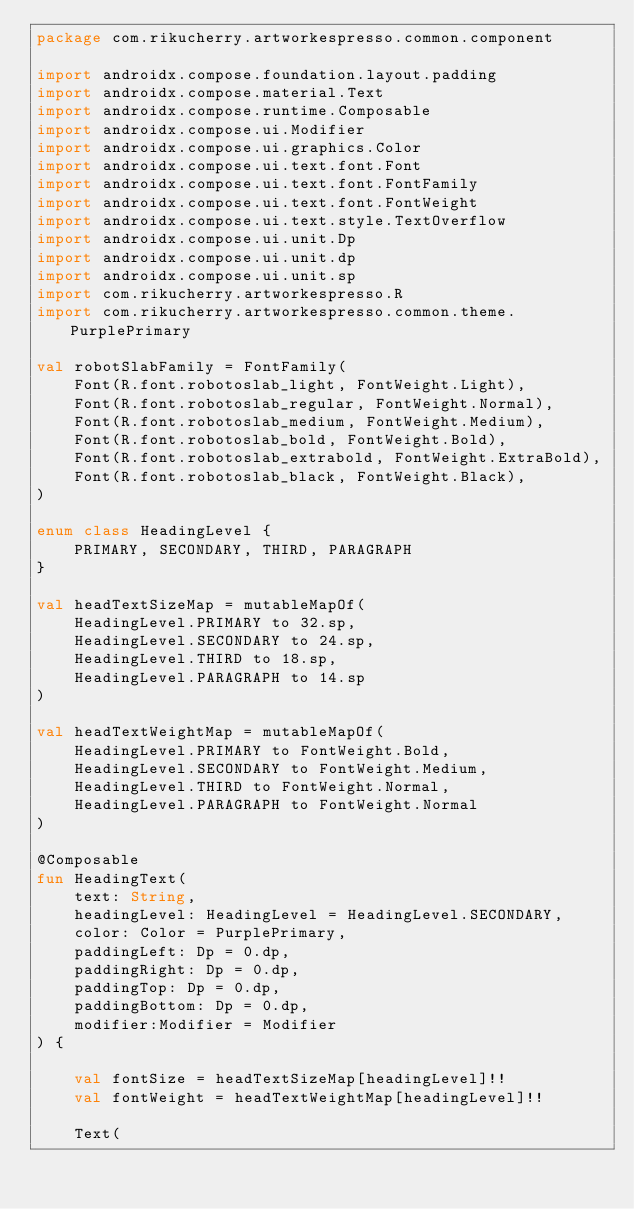Convert code to text. <code><loc_0><loc_0><loc_500><loc_500><_Kotlin_>package com.rikucherry.artworkespresso.common.component

import androidx.compose.foundation.layout.padding
import androidx.compose.material.Text
import androidx.compose.runtime.Composable
import androidx.compose.ui.Modifier
import androidx.compose.ui.graphics.Color
import androidx.compose.ui.text.font.Font
import androidx.compose.ui.text.font.FontFamily
import androidx.compose.ui.text.font.FontWeight
import androidx.compose.ui.text.style.TextOverflow
import androidx.compose.ui.unit.Dp
import androidx.compose.ui.unit.dp
import androidx.compose.ui.unit.sp
import com.rikucherry.artworkespresso.R
import com.rikucherry.artworkespresso.common.theme.PurplePrimary

val robotSlabFamily = FontFamily(
    Font(R.font.robotoslab_light, FontWeight.Light),
    Font(R.font.robotoslab_regular, FontWeight.Normal),
    Font(R.font.robotoslab_medium, FontWeight.Medium),
    Font(R.font.robotoslab_bold, FontWeight.Bold),
    Font(R.font.robotoslab_extrabold, FontWeight.ExtraBold),
    Font(R.font.robotoslab_black, FontWeight.Black),
)

enum class HeadingLevel {
    PRIMARY, SECONDARY, THIRD, PARAGRAPH
}

val headTextSizeMap = mutableMapOf(
    HeadingLevel.PRIMARY to 32.sp,
    HeadingLevel.SECONDARY to 24.sp,
    HeadingLevel.THIRD to 18.sp,
    HeadingLevel.PARAGRAPH to 14.sp
)

val headTextWeightMap = mutableMapOf(
    HeadingLevel.PRIMARY to FontWeight.Bold,
    HeadingLevel.SECONDARY to FontWeight.Medium,
    HeadingLevel.THIRD to FontWeight.Normal,
    HeadingLevel.PARAGRAPH to FontWeight.Normal
)

@Composable
fun HeadingText(
    text: String,
    headingLevel: HeadingLevel = HeadingLevel.SECONDARY,
    color: Color = PurplePrimary,
    paddingLeft: Dp = 0.dp,
    paddingRight: Dp = 0.dp,
    paddingTop: Dp = 0.dp,
    paddingBottom: Dp = 0.dp,
    modifier:Modifier = Modifier
) {

    val fontSize = headTextSizeMap[headingLevel]!!
    val fontWeight = headTextWeightMap[headingLevel]!!

    Text(</code> 